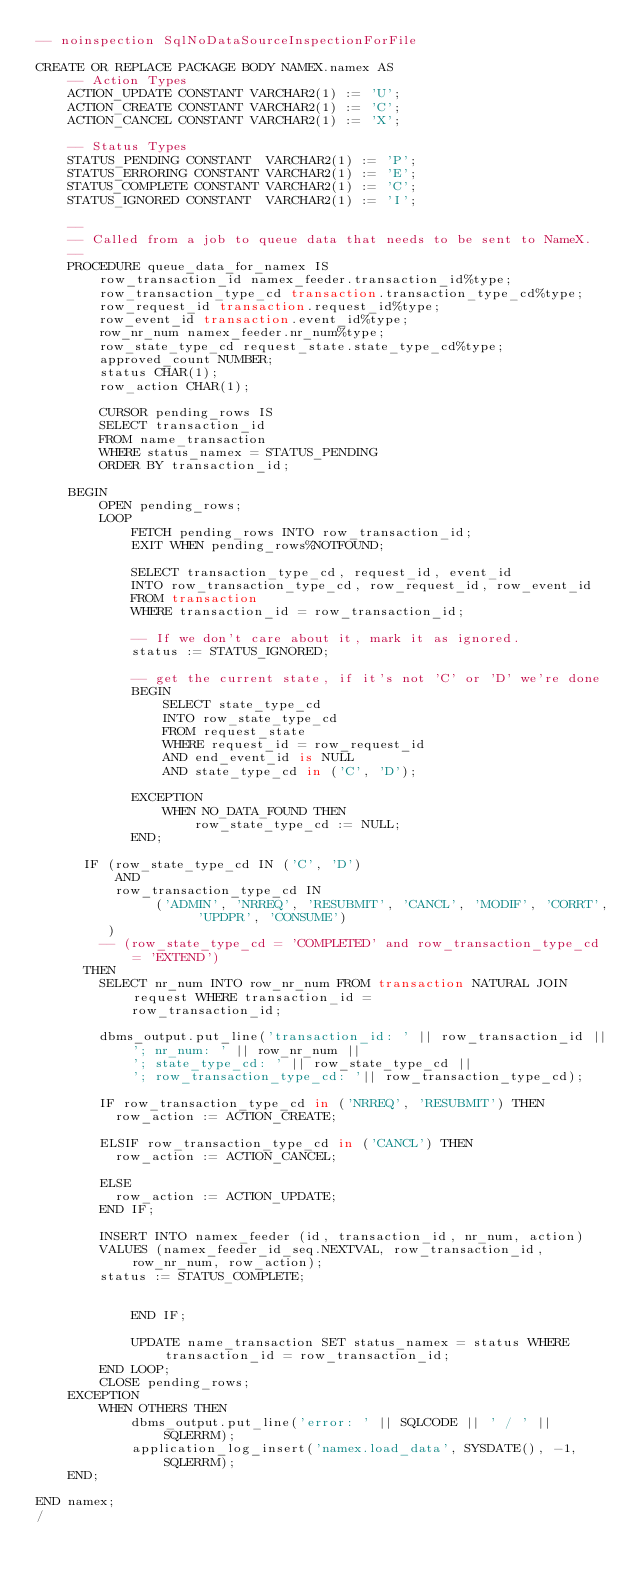<code> <loc_0><loc_0><loc_500><loc_500><_SQL_>-- noinspection SqlNoDataSourceInspectionForFile

CREATE OR REPLACE PACKAGE BODY NAMEX.namex AS
    -- Action Types
    ACTION_UPDATE CONSTANT VARCHAR2(1) := 'U';
    ACTION_CREATE CONSTANT VARCHAR2(1) := 'C';
    ACTION_CANCEL CONSTANT VARCHAR2(1) := 'X';

    -- Status Types
    STATUS_PENDING CONSTANT  VARCHAR2(1) := 'P';
    STATUS_ERRORING CONSTANT VARCHAR2(1) := 'E';
    STATUS_COMPLETE CONSTANT VARCHAR2(1) := 'C';
    STATUS_IGNORED CONSTANT  VARCHAR2(1) := 'I';

    --
    -- Called from a job to queue data that needs to be sent to NameX.
    --
    PROCEDURE queue_data_for_namex IS
        row_transaction_id namex_feeder.transaction_id%type;
        row_transaction_type_cd transaction.transaction_type_cd%type;
        row_request_id transaction.request_id%type;
        row_event_id transaction.event_id%type;
        row_nr_num namex_feeder.nr_num%type;
        row_state_type_cd request_state.state_type_cd%type;
        approved_count NUMBER;
        status CHAR(1);
        row_action CHAR(1);

        CURSOR pending_rows IS 
        SELECT transaction_id 
        FROM name_transaction 
        WHERE status_namex = STATUS_PENDING
        ORDER BY transaction_id;
        
    BEGIN
        OPEN pending_rows;
        LOOP
            FETCH pending_rows INTO row_transaction_id;
            EXIT WHEN pending_rows%NOTFOUND;

            SELECT transaction_type_cd, request_id, event_id
            INTO row_transaction_type_cd, row_request_id, row_event_id
            FROM transaction 
            WHERE transaction_id = row_transaction_id;

            -- If we don't care about it, mark it as ignored.
            status := STATUS_IGNORED;

            -- get the current state, if it's not 'C' or 'D' we're done
            BEGIN
                SELECT state_type_cd 
                INTO row_state_type_cd 
                FROM request_state 
                WHERE request_id = row_request_id
                AND end_event_id is NULL
                AND state_type_cd in ('C', 'D');
                
            EXCEPTION
                WHEN NO_DATA_FOUND THEN
                    row_state_type_cd := NULL;
            END;

			IF (row_state_type_cd IN ('C', 'D')
			    AND 
			    row_transaction_type_cd IN 
			         ('ADMIN', 'NRREQ', 'RESUBMIT', 'CANCL', 'MODIF', 'CORRT', 'UPDPR', 'CONSUME')
			   )
			  -- (row_state_type_cd = 'COMPLETED' and row_transaction_type_cd = 'EXTEND')
			THEN
				SELECT nr_num INTO row_nr_num FROM transaction NATURAL JOIN request WHERE transaction_id =
						row_transaction_id;

				dbms_output.put_line('transaction_id: ' || row_transaction_id ||
						'; nr_num: ' || row_nr_num ||
						'; state_type_cd: ' || row_state_type_cd ||
						'; row_transaction_type_cd: '|| row_transaction_type_cd);

				IF row_transaction_type_cd in ('NRREQ', 'RESUBMIT') THEN
					row_action := ACTION_CREATE;
					
				ELSIF row_transaction_type_cd in ('CANCL') THEN
					row_action := ACTION_CANCEL;
					
				ELSE
					row_action := ACTION_UPDATE;
				END IF;

				INSERT INTO namex_feeder (id, transaction_id, nr_num, action)
				VALUES (namex_feeder_id_seq.NEXTVAL, row_transaction_id, row_nr_num, row_action);
				status := STATUS_COMPLETE;


            END IF;

            UPDATE name_transaction SET status_namex = status WHERE transaction_id = row_transaction_id;
        END LOOP;
        CLOSE pending_rows;
    EXCEPTION
        WHEN OTHERS THEN
            dbms_output.put_line('error: ' || SQLCODE || ' / ' || SQLERRM);
            application_log_insert('namex.load_data', SYSDATE(), -1, SQLERRM);
    END;

END namex;
/
</code> 